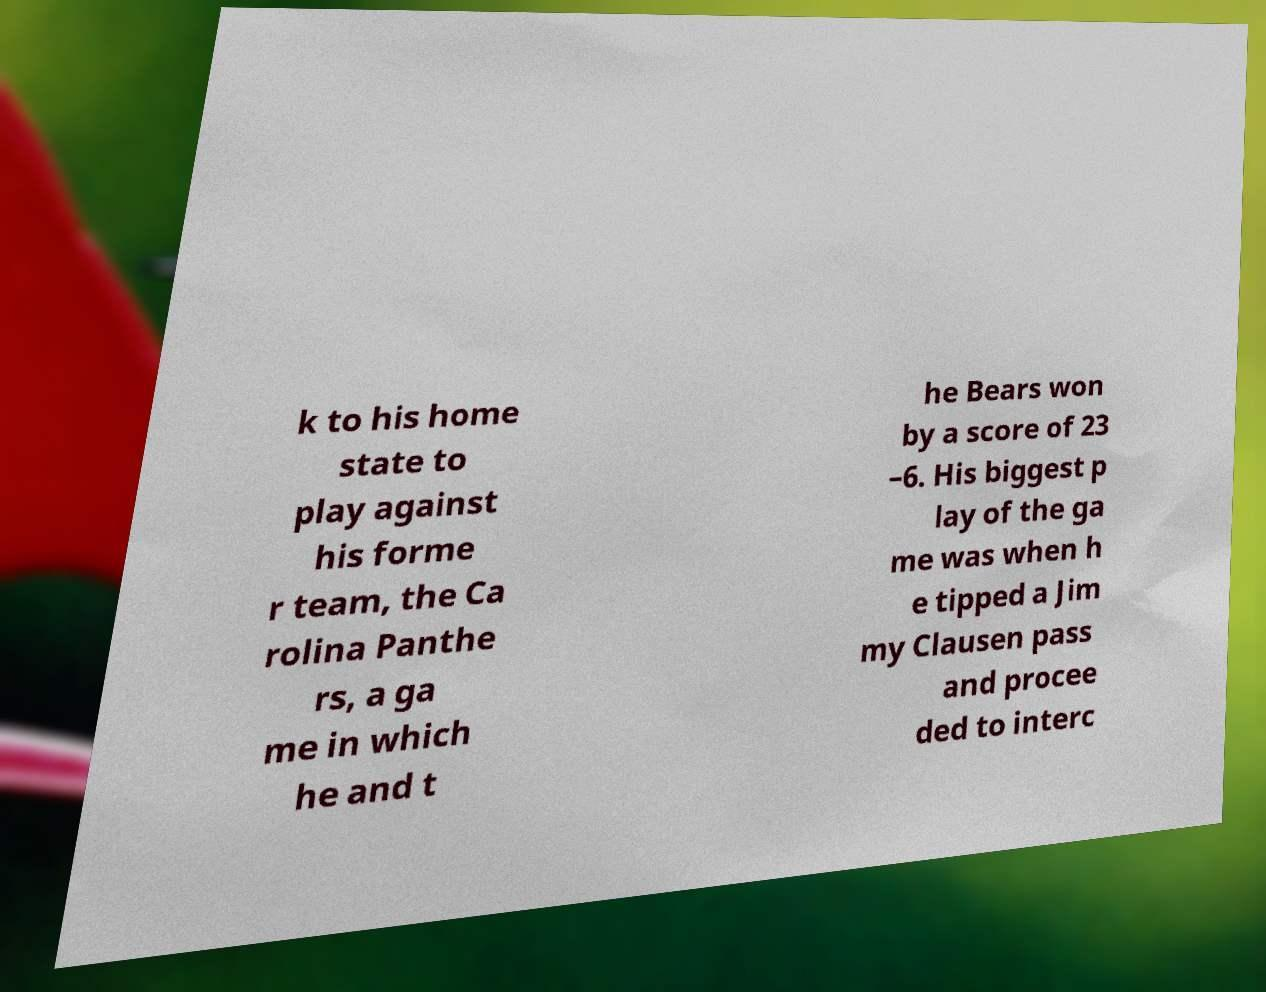Could you extract and type out the text from this image? k to his home state to play against his forme r team, the Ca rolina Panthe rs, a ga me in which he and t he Bears won by a score of 23 –6. His biggest p lay of the ga me was when h e tipped a Jim my Clausen pass and procee ded to interc 